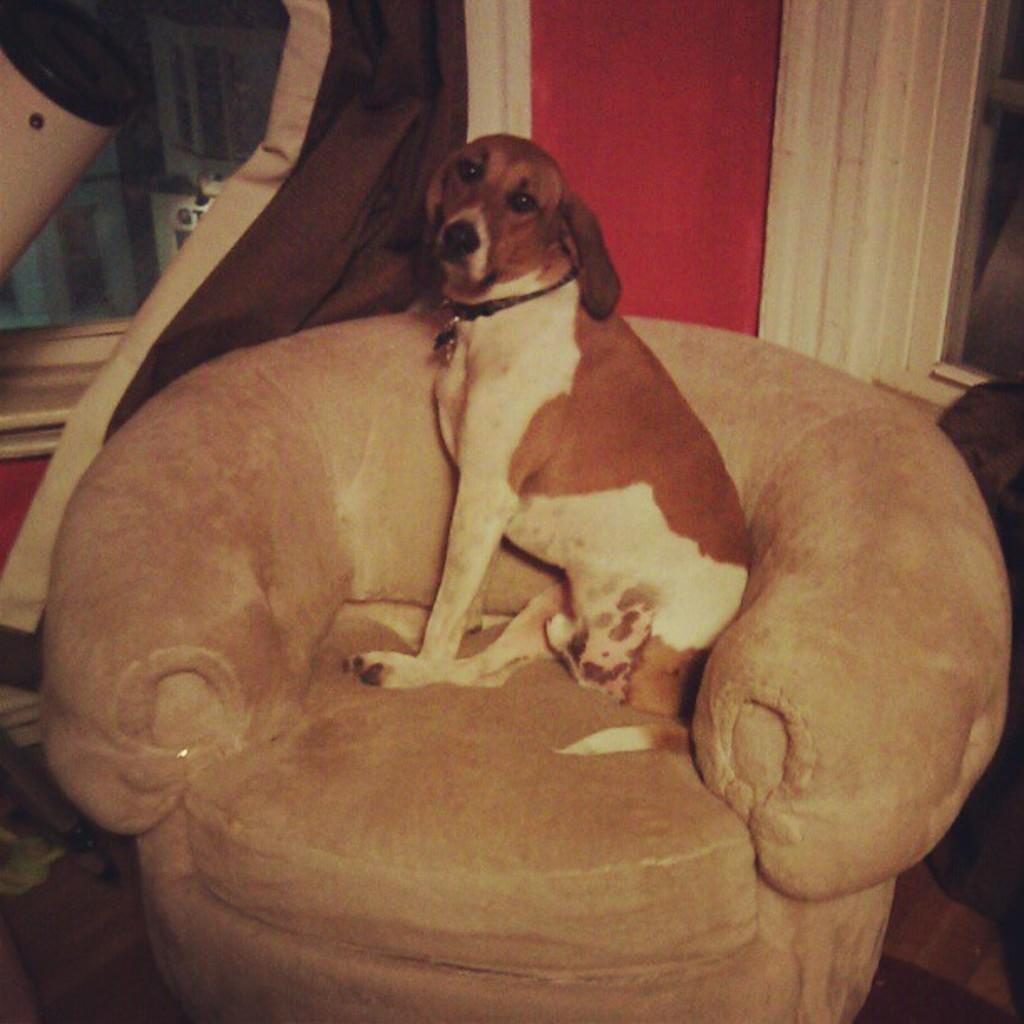What animal is present in the image? There is a dog in the image. What is the dog doing in the image? The dog is sitting on a chair. Can you describe the background of the image? There are objects in the background of the image. How many snails can be seen crawling on the bike in the image? There is no bike or snails present in the image; it features a dog sitting on a chair. What type of wood is used to make the chair the dog is sitting on? The type of wood used to make the chair is not mentioned or visible in the image. 